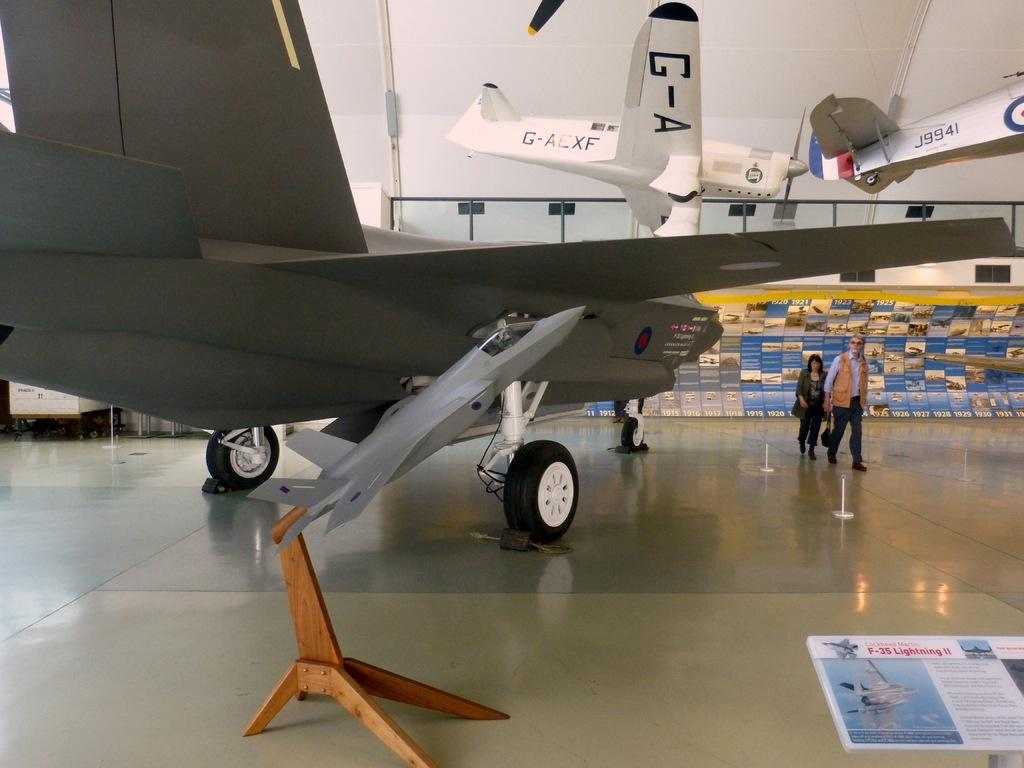<image>
Provide a brief description of the given image. An airplane museum includes a G-AEXF airplane, and one coded J9941. 